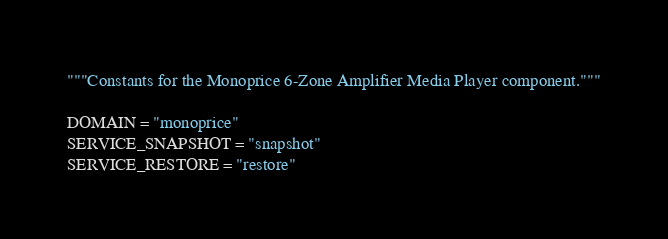<code> <loc_0><loc_0><loc_500><loc_500><_Python_>"""Constants for the Monoprice 6-Zone Amplifier Media Player component."""

DOMAIN = "monoprice"
SERVICE_SNAPSHOT = "snapshot"
SERVICE_RESTORE = "restore"
</code> 